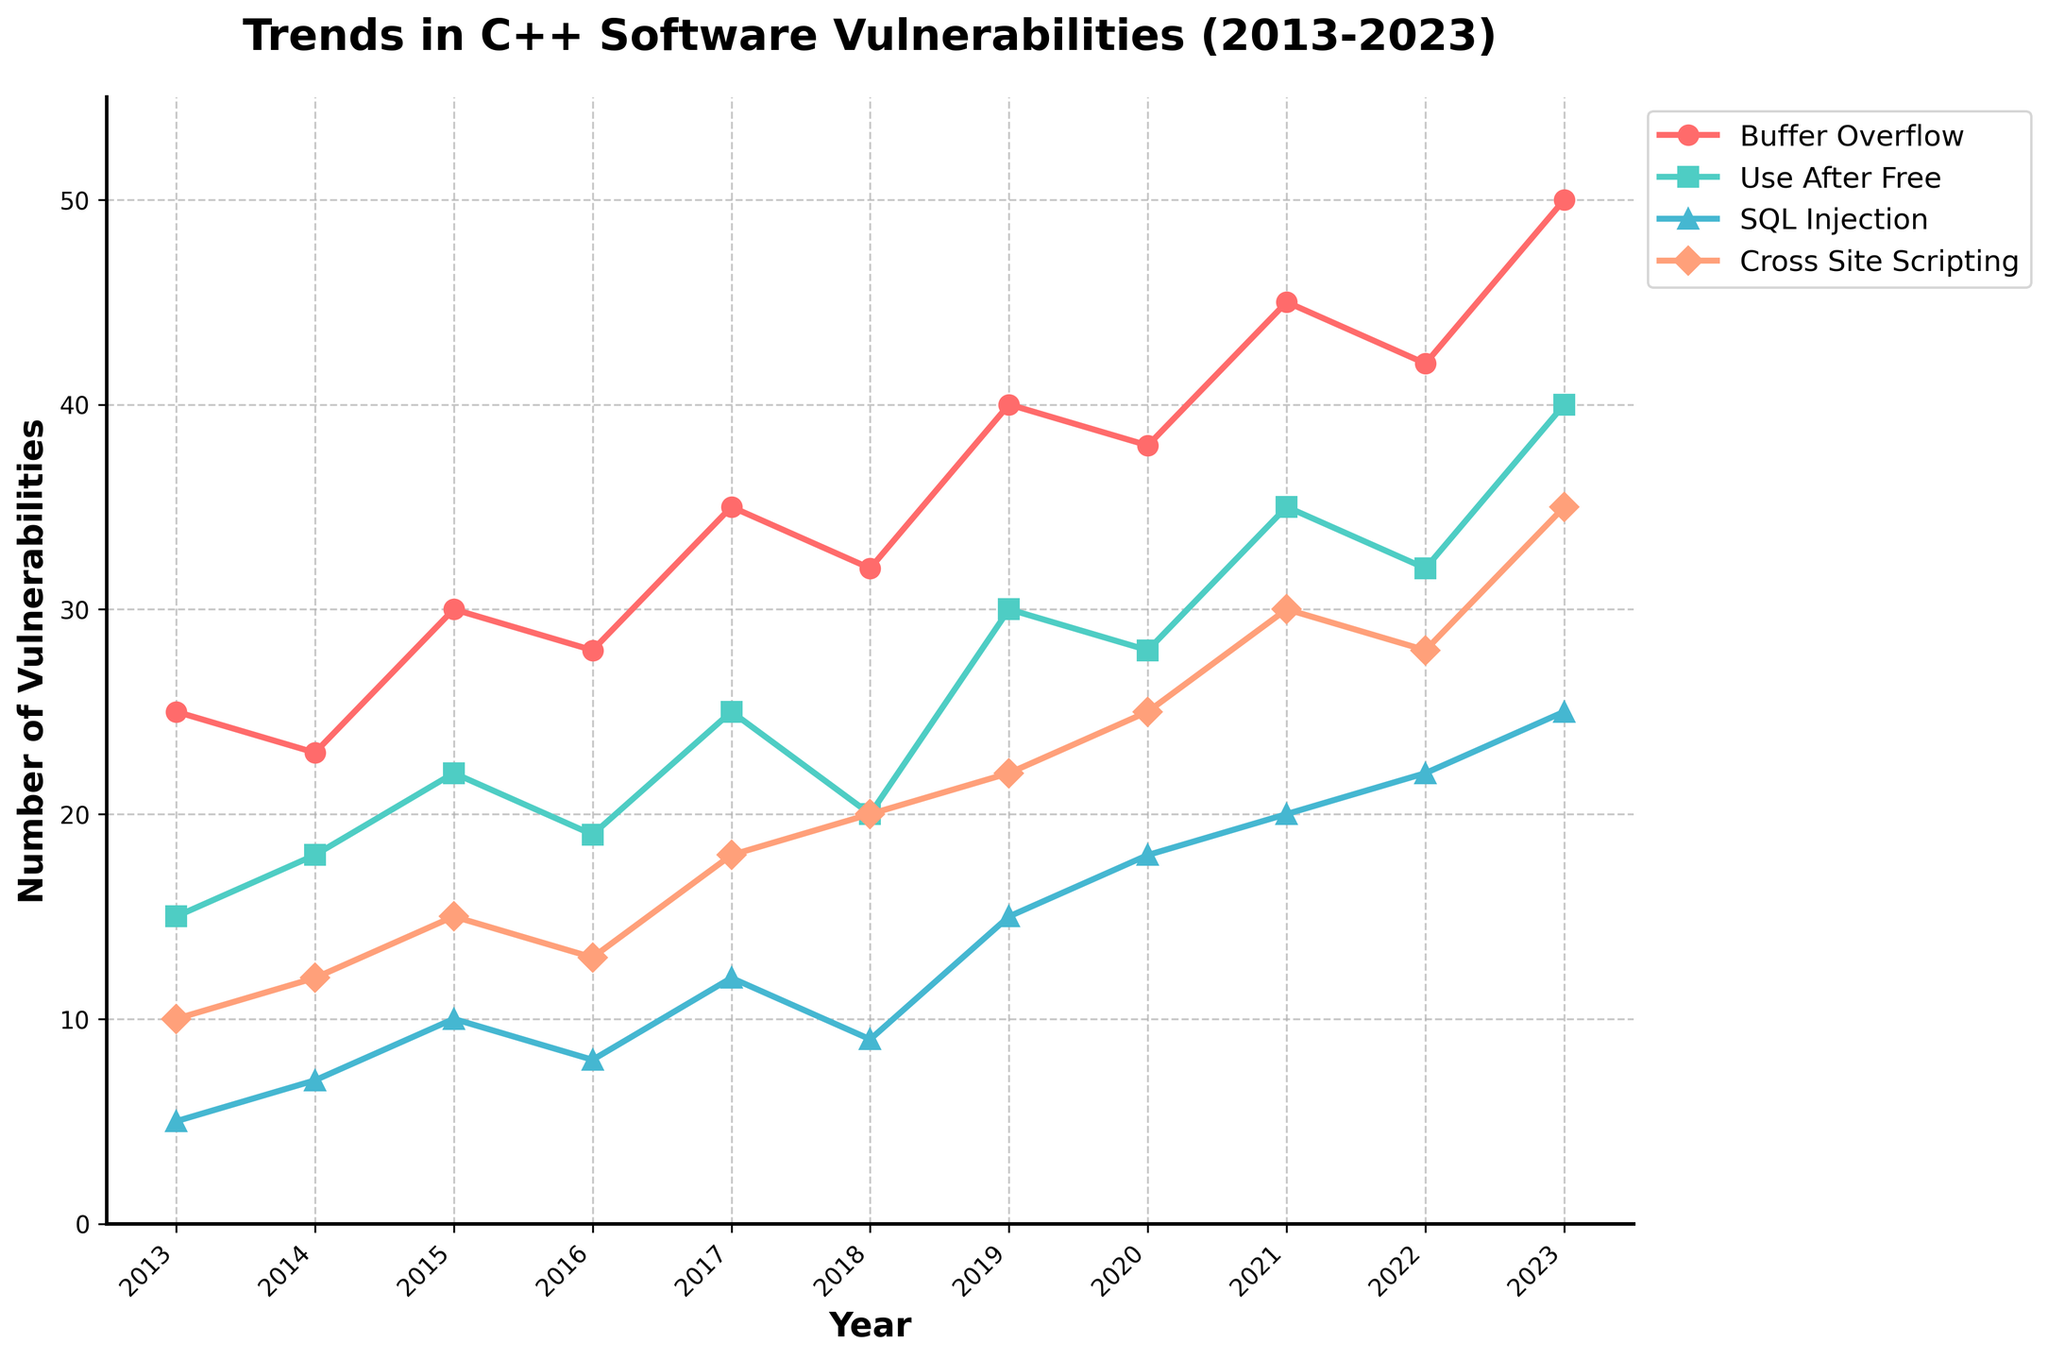What is the title of the figure? The title of the figure is written at the top and describes the overall content of the plot.
Answer: Trends in C++ Software Vulnerabilities (2013-2023) What are the four types of vulnerabilities tracked in the figure? The types of vulnerabilities are indicated in the legend on the right side of the plot.
Answer: Buffer Overflow, Use After Free, SQL Injection, Cross Site Scripting In which year was the highest number of Buffer Overflow vulnerabilities reported? By observing the peaks of the Buffer Overflow line (the color associated is noted), find the highest point and its corresponding year on the x-axis.
Answer: 2023 What is the average number of SQL Injection vulnerabilities over the 10-year period? Add the number of SQL Injection vulnerabilities for each year and divide by the total number of years (10). (5 + 7 + 10 + 8 + 12 + 9 + 15 + 18 + 20 + 22 + 25) / 11
Answer: Approximately 13.18 Which year saw the greatest increase in Cross Site Scripting vulnerabilities compared to the previous year? Calculate the year-on-year difference for Cross Site Scripting counts and identify the largest increase.
Answer: 2020 Are there more Use After Free vulnerabilities or SQL Injection vulnerabilities in 2021? Compare the plotted points for Use After Free and SQL Injection for the year 2021. Use After Free has 35, SQL Injection has 20.
Answer: Use After Free What is the overall trend in the number of Buffer Overflow vulnerabilities from 2013 to 2023? Look at the general direction of the Buffer Overflow line over the years. It shows an increasing trend.
Answer: Increasing Compare the number of vulnerabilities for Buffer Overflow and Cross Site Scripting in 2016. Identify and compare the values for both vulnerabilities in the year 2016 from the plot. Buffer Overflow is 28, Cross Site Scripting is 13.
Answer: Buffer Overflow has more Which vulnerability type shows the most variability in its trend over the 10-year period? Observe the fluctuations in the lines for each vulnerability type. The one with the most rises and falls is noted for variability.
Answer: Cross Site Scripting What is the minimum number of Use After Free vulnerabilities reported in any year, and in which year? Identify the lowest value point on the Use After Free line and note its corresponding year.
Answer: 15, in 2013 